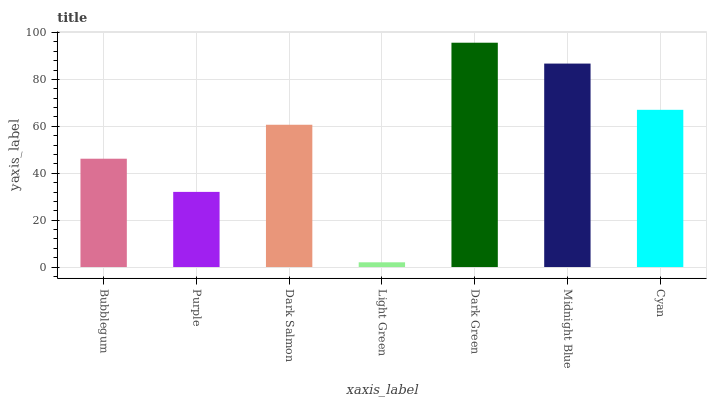Is Light Green the minimum?
Answer yes or no. Yes. Is Dark Green the maximum?
Answer yes or no. Yes. Is Purple the minimum?
Answer yes or no. No. Is Purple the maximum?
Answer yes or no. No. Is Bubblegum greater than Purple?
Answer yes or no. Yes. Is Purple less than Bubblegum?
Answer yes or no. Yes. Is Purple greater than Bubblegum?
Answer yes or no. No. Is Bubblegum less than Purple?
Answer yes or no. No. Is Dark Salmon the high median?
Answer yes or no. Yes. Is Dark Salmon the low median?
Answer yes or no. Yes. Is Cyan the high median?
Answer yes or no. No. Is Bubblegum the low median?
Answer yes or no. No. 